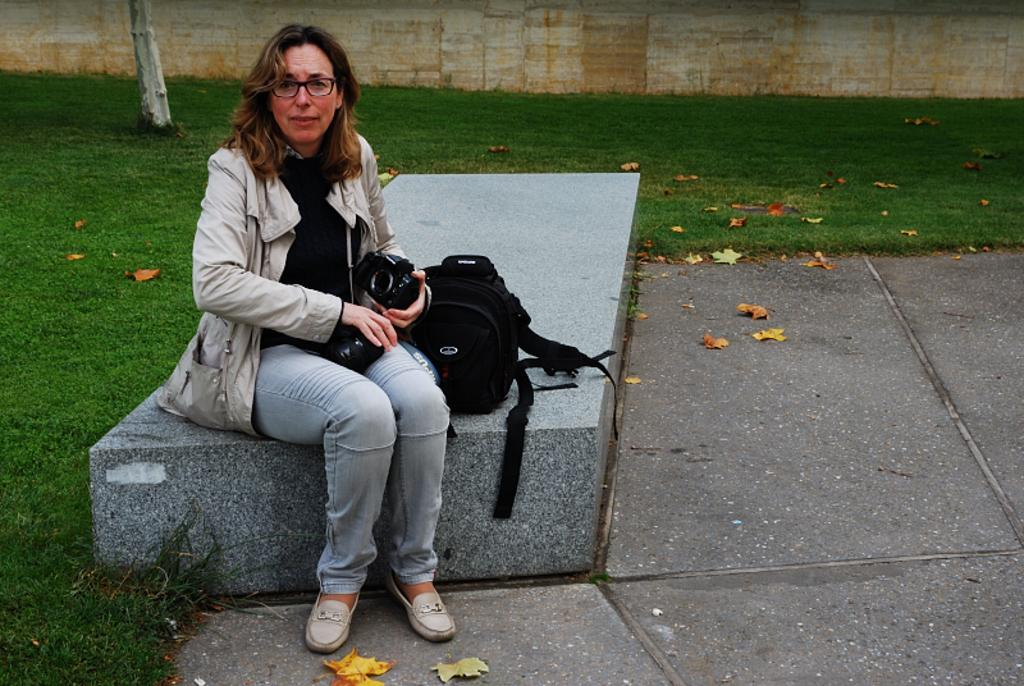Who is the main subject in the image? There is a lady in the image. What is the lady holding in the image? The lady is holding a camera. Where is the lady sitting in the image? The lady is sitting on a rock. What other item can be seen in the image? There is a bag in the image. What is visible in the background of the image? There is a wall in the background of the image. What type of vegetation is visible at the bottom of the image? There is grass at the bottom of the image. What else can be seen in the image? Leaves are visible in the image. What type of cast can be seen on the lady's arm in the image? There is no cast visible on the lady's arm in the image. What is the rail used for in the image? There is no rail present in the image. 